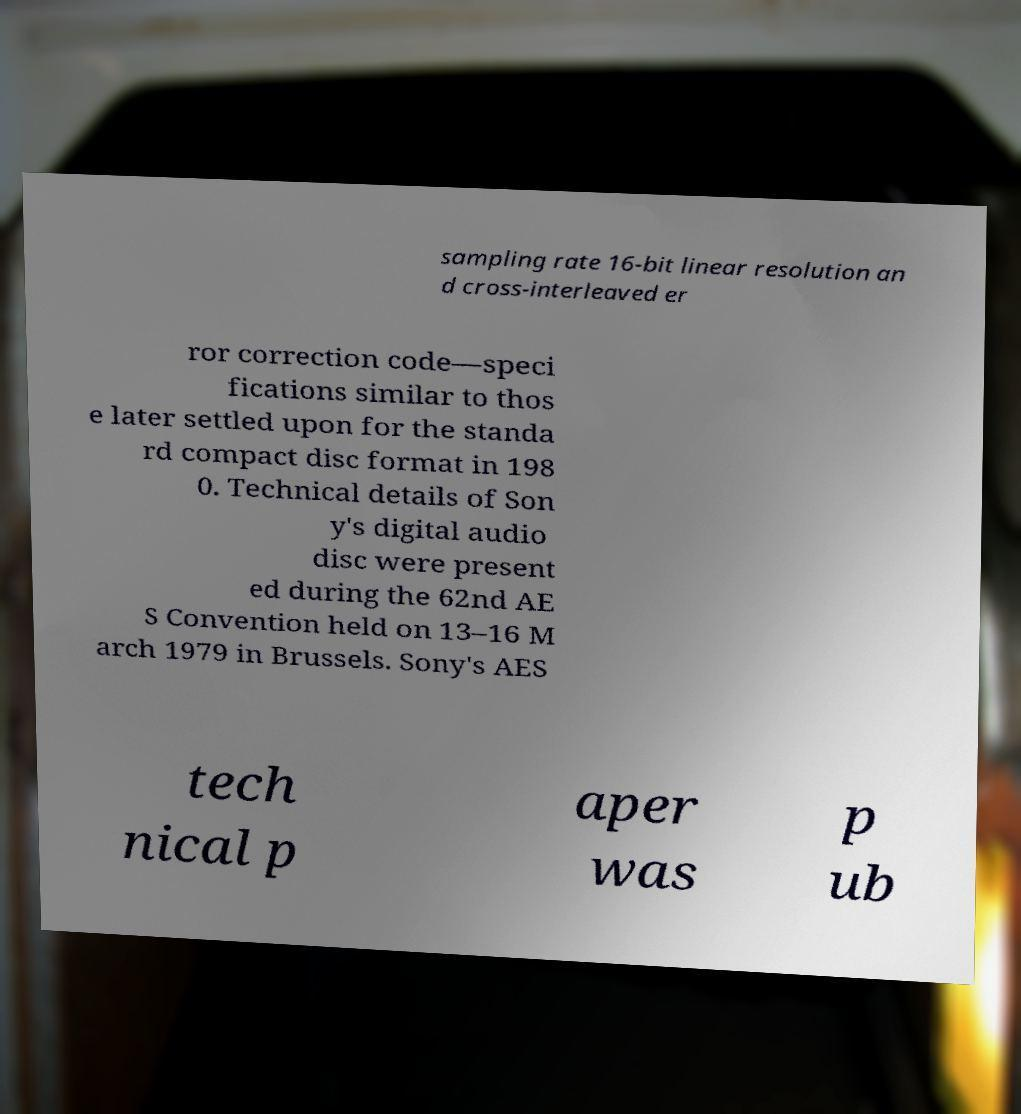Could you assist in decoding the text presented in this image and type it out clearly? sampling rate 16-bit linear resolution an d cross-interleaved er ror correction code—speci fications similar to thos e later settled upon for the standa rd compact disc format in 198 0. Technical details of Son y's digital audio disc were present ed during the 62nd AE S Convention held on 13–16 M arch 1979 in Brussels. Sony's AES tech nical p aper was p ub 